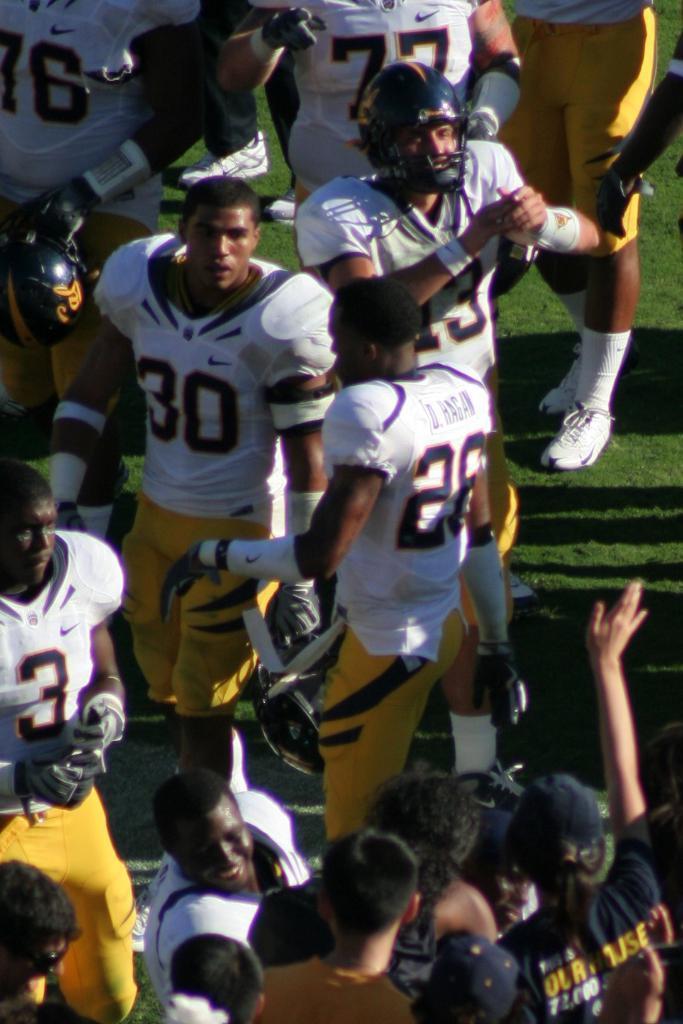In one or two sentences, can you explain what this image depicts? In the picture we can see some persons wearing white and yellow color sports dress standing in ground. 